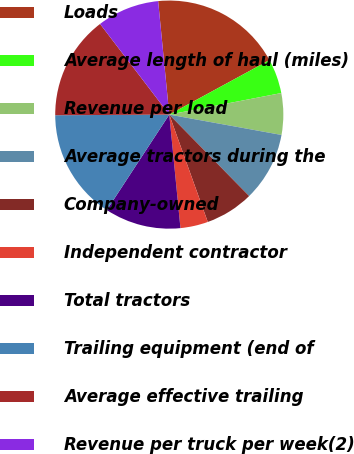Convert chart. <chart><loc_0><loc_0><loc_500><loc_500><pie_chart><fcel>Loads<fcel>Average length of haul (miles)<fcel>Revenue per load<fcel>Average tractors during the<fcel>Company-owned<fcel>Independent contractor<fcel>Total tractors<fcel>Trailing equipment (end of<fcel>Average effective trailing<fcel>Revenue per truck per week(2)<nl><fcel>18.63%<fcel>4.9%<fcel>5.88%<fcel>9.8%<fcel>6.86%<fcel>3.92%<fcel>10.78%<fcel>15.69%<fcel>14.71%<fcel>8.82%<nl></chart> 